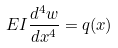Convert formula to latex. <formula><loc_0><loc_0><loc_500><loc_500>E I \frac { d ^ { 4 } w } { d x ^ { 4 } } = q ( x )</formula> 